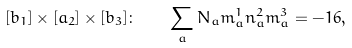<formula> <loc_0><loc_0><loc_500><loc_500>[ b _ { 1 } ] \times [ a _ { 2 } ] \times [ b _ { 3 } ] \colon \quad \sum _ { a } N _ { a } m _ { a } ^ { 1 } n _ { a } ^ { 2 } m _ { a } ^ { 3 } = - 1 6 , \\</formula> 